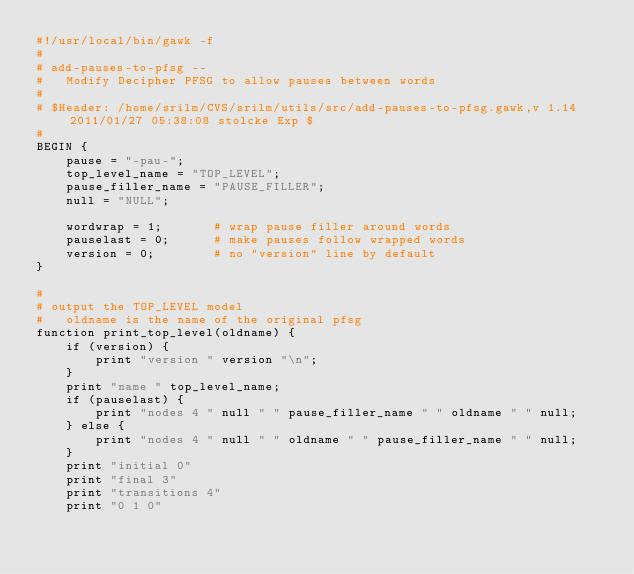<code> <loc_0><loc_0><loc_500><loc_500><_Awk_>#!/usr/local/bin/gawk -f
#
# add-pauses-to-pfsg --
#	Modify Decipher PFSG to allow pauses between words
#
# $Header: /home/srilm/CVS/srilm/utils/src/add-pauses-to-pfsg.gawk,v 1.14 2011/01/27 05:38:08 stolcke Exp $
#
BEGIN {
	pause = "-pau-";
	top_level_name = "TOP_LEVEL";
	pause_filler_name = "PAUSE_FILLER";
	null = "NULL";

	wordwrap = 1;		# wrap pause filler around words
	pauselast = 0;		# make pauses follow wrapped words
	version = 0;		# no "version" line by default
}

#
# output the TOP_LEVEL model
#	oldname is the name of the original pfsg
function print_top_level(oldname) {
	if (version) {
		print "version " version "\n";
	}
	print "name " top_level_name;
	if (pauselast) {
	    print "nodes 4 " null " " pause_filler_name " " oldname " " null;
	} else {
	    print "nodes 4 " null " " oldname " " pause_filler_name " " null;
	}
	print "initial 0"
	print "final 3"
	print "transitions 4"
	print "0 1 0"</code> 